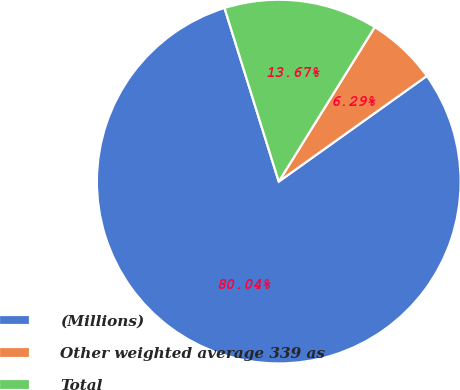Convert chart. <chart><loc_0><loc_0><loc_500><loc_500><pie_chart><fcel>(Millions)<fcel>Other weighted average 339 as<fcel>Total<nl><fcel>80.04%<fcel>6.29%<fcel>13.67%<nl></chart> 